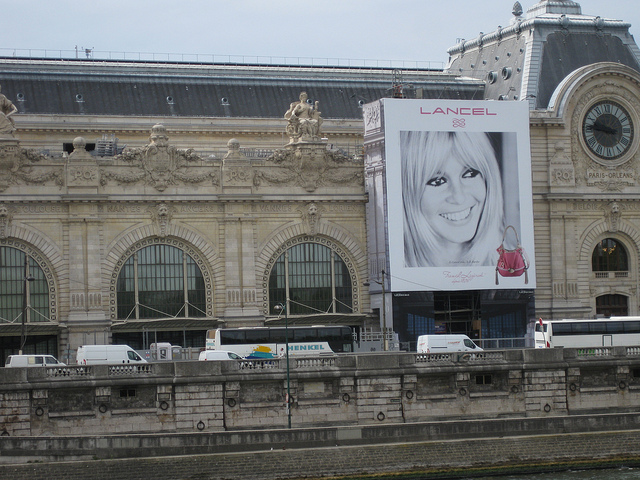Identify the text contained in this image. LANCEL HENKEL II 